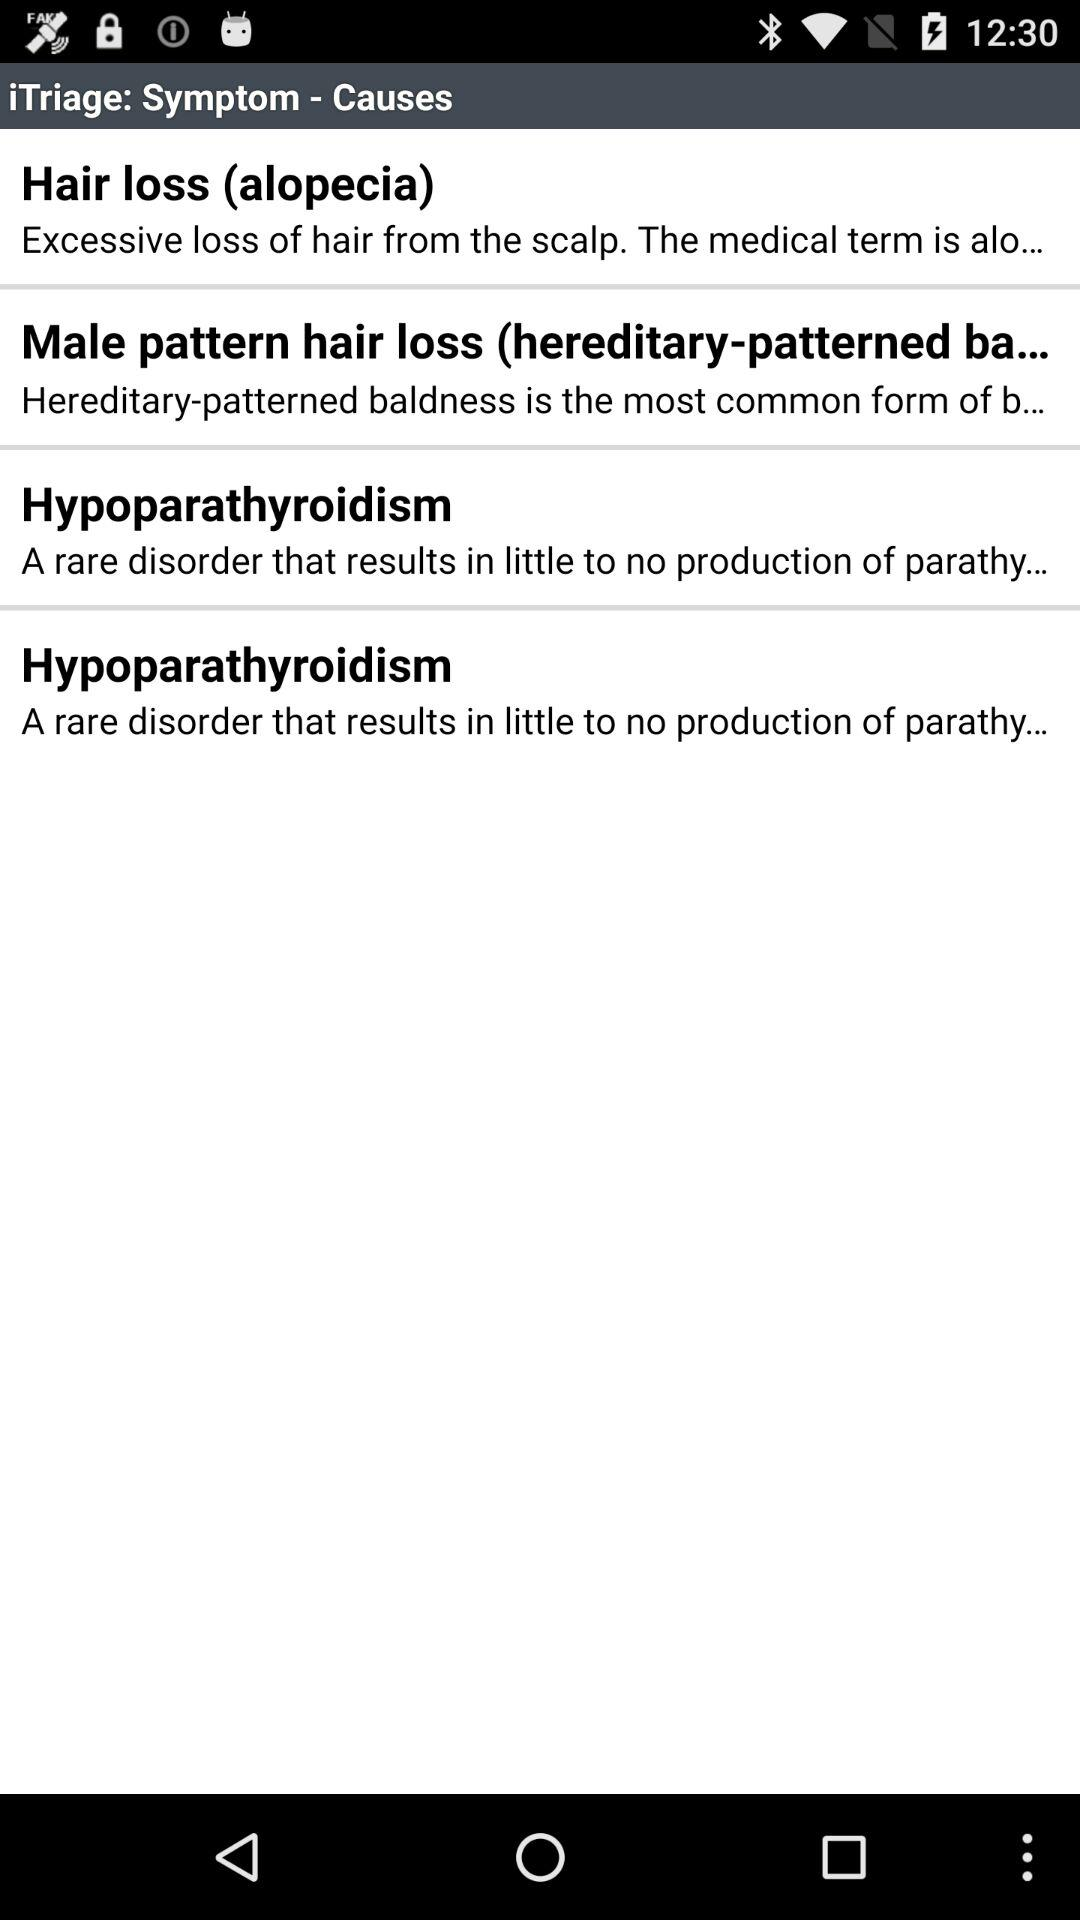What is alopecia? Alopecia is "Excessive loss of hair from the scalp". 